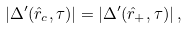<formula> <loc_0><loc_0><loc_500><loc_500>| \Delta ^ { \prime } ( \hat { r } _ { c } , \tau ) | = | \Delta ^ { \prime } ( \hat { r } _ { + } , \tau ) | \, ,</formula> 